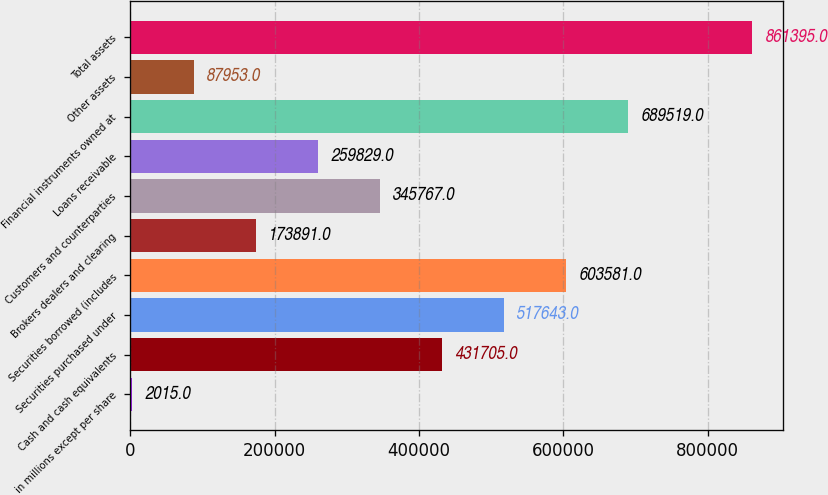Convert chart. <chart><loc_0><loc_0><loc_500><loc_500><bar_chart><fcel>in millions except per share<fcel>Cash and cash equivalents<fcel>Securities purchased under<fcel>Securities borrowed (includes<fcel>Brokers dealers and clearing<fcel>Customers and counterparties<fcel>Loans receivable<fcel>Financial instruments owned at<fcel>Other assets<fcel>Total assets<nl><fcel>2015<fcel>431705<fcel>517643<fcel>603581<fcel>173891<fcel>345767<fcel>259829<fcel>689519<fcel>87953<fcel>861395<nl></chart> 